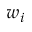<formula> <loc_0><loc_0><loc_500><loc_500>w _ { i }</formula> 